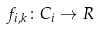<formula> <loc_0><loc_0><loc_500><loc_500>f _ { i , k } \colon C _ { i } \rightarrow R</formula> 